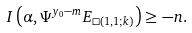<formula> <loc_0><loc_0><loc_500><loc_500>I \left ( \alpha , \Psi ^ { y _ { 0 } - m } E _ { \Box ( 1 , 1 ; k ) } \right ) \geq - n .</formula> 